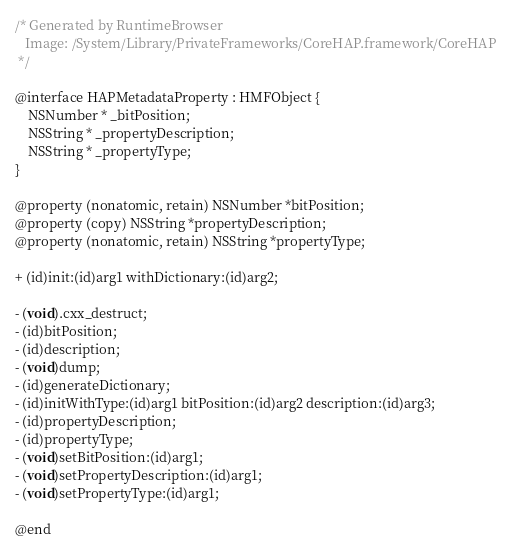<code> <loc_0><loc_0><loc_500><loc_500><_C_>/* Generated by RuntimeBrowser
   Image: /System/Library/PrivateFrameworks/CoreHAP.framework/CoreHAP
 */

@interface HAPMetadataProperty : HMFObject {
    NSNumber * _bitPosition;
    NSString * _propertyDescription;
    NSString * _propertyType;
}

@property (nonatomic, retain) NSNumber *bitPosition;
@property (copy) NSString *propertyDescription;
@property (nonatomic, retain) NSString *propertyType;

+ (id)init:(id)arg1 withDictionary:(id)arg2;

- (void).cxx_destruct;
- (id)bitPosition;
- (id)description;
- (void)dump;
- (id)generateDictionary;
- (id)initWithType:(id)arg1 bitPosition:(id)arg2 description:(id)arg3;
- (id)propertyDescription;
- (id)propertyType;
- (void)setBitPosition:(id)arg1;
- (void)setPropertyDescription:(id)arg1;
- (void)setPropertyType:(id)arg1;

@end
</code> 